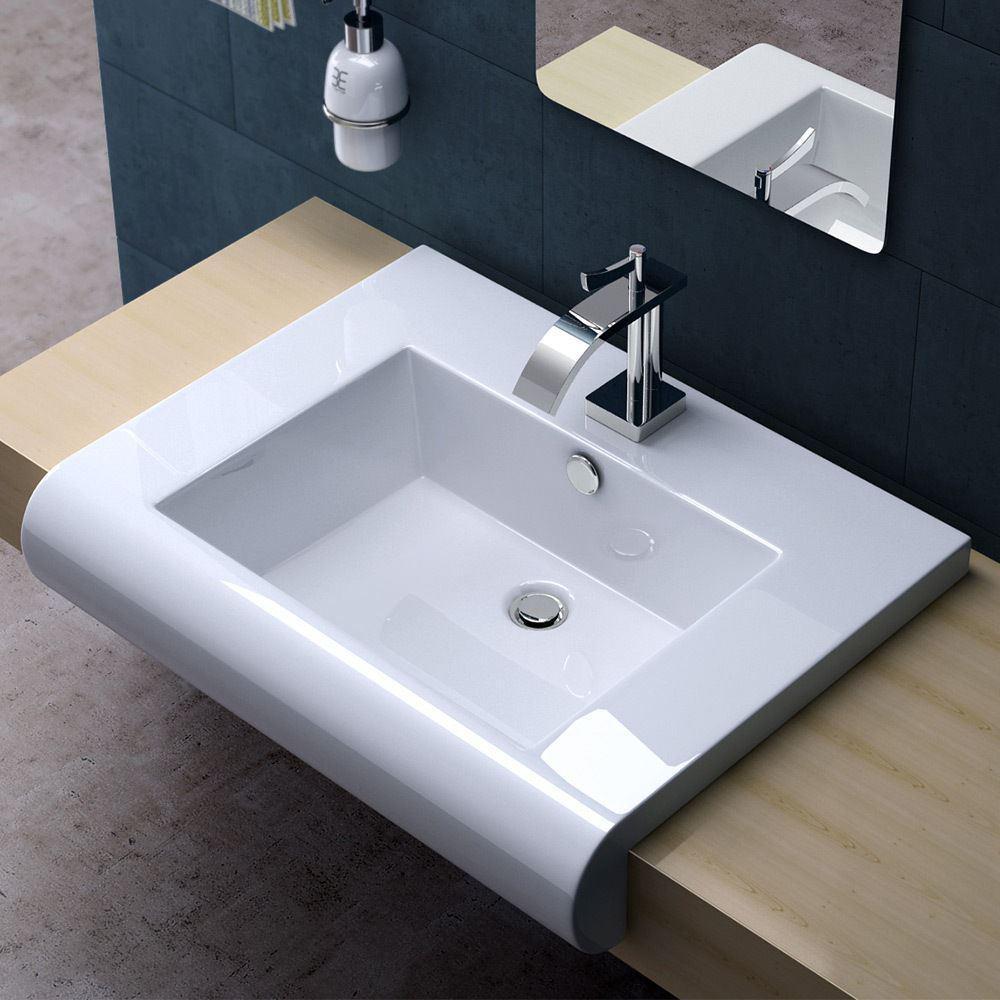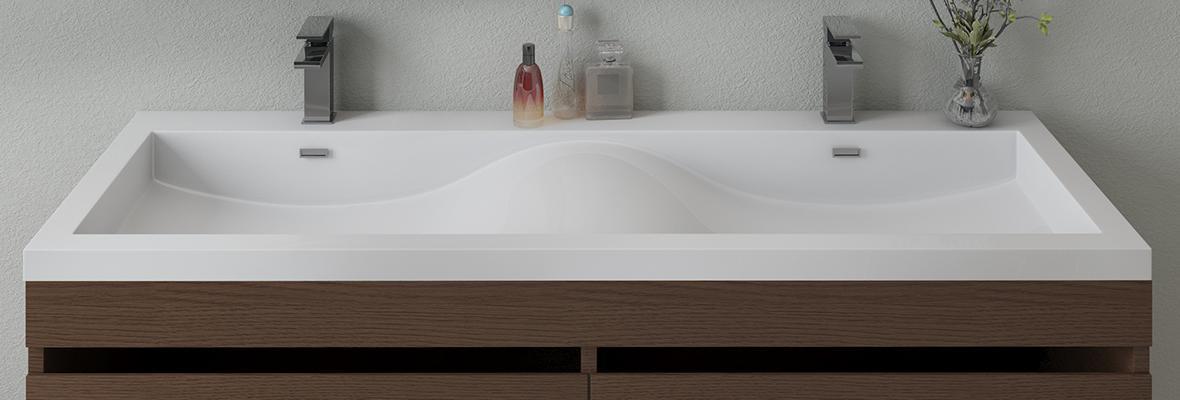The first image is the image on the left, the second image is the image on the right. For the images displayed, is the sentence "One image shows a single sink and the other shows two adjacent sinks." factually correct? Answer yes or no. Yes. 